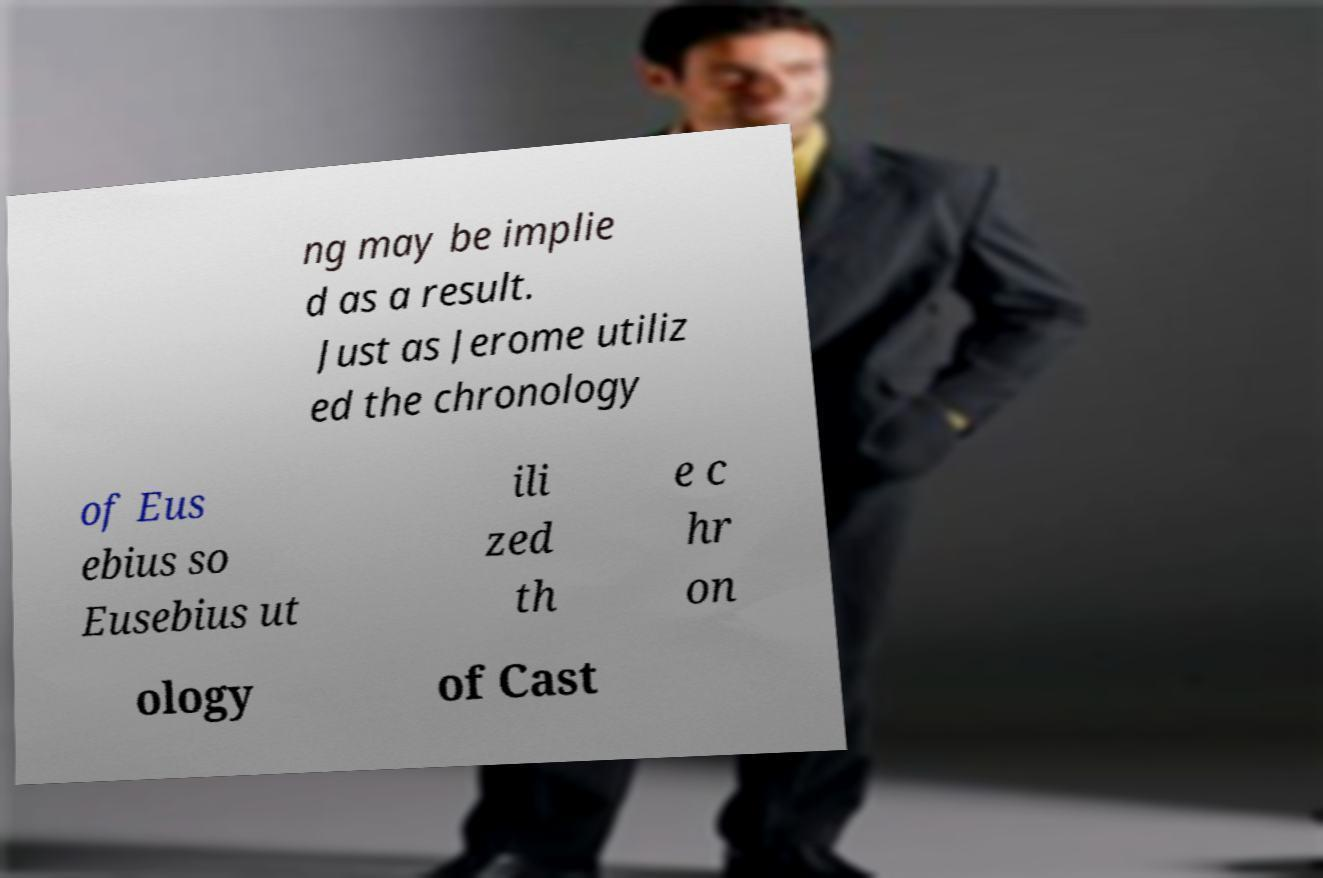For documentation purposes, I need the text within this image transcribed. Could you provide that? ng may be implie d as a result. Just as Jerome utiliz ed the chronology of Eus ebius so Eusebius ut ili zed th e c hr on ology of Cast 